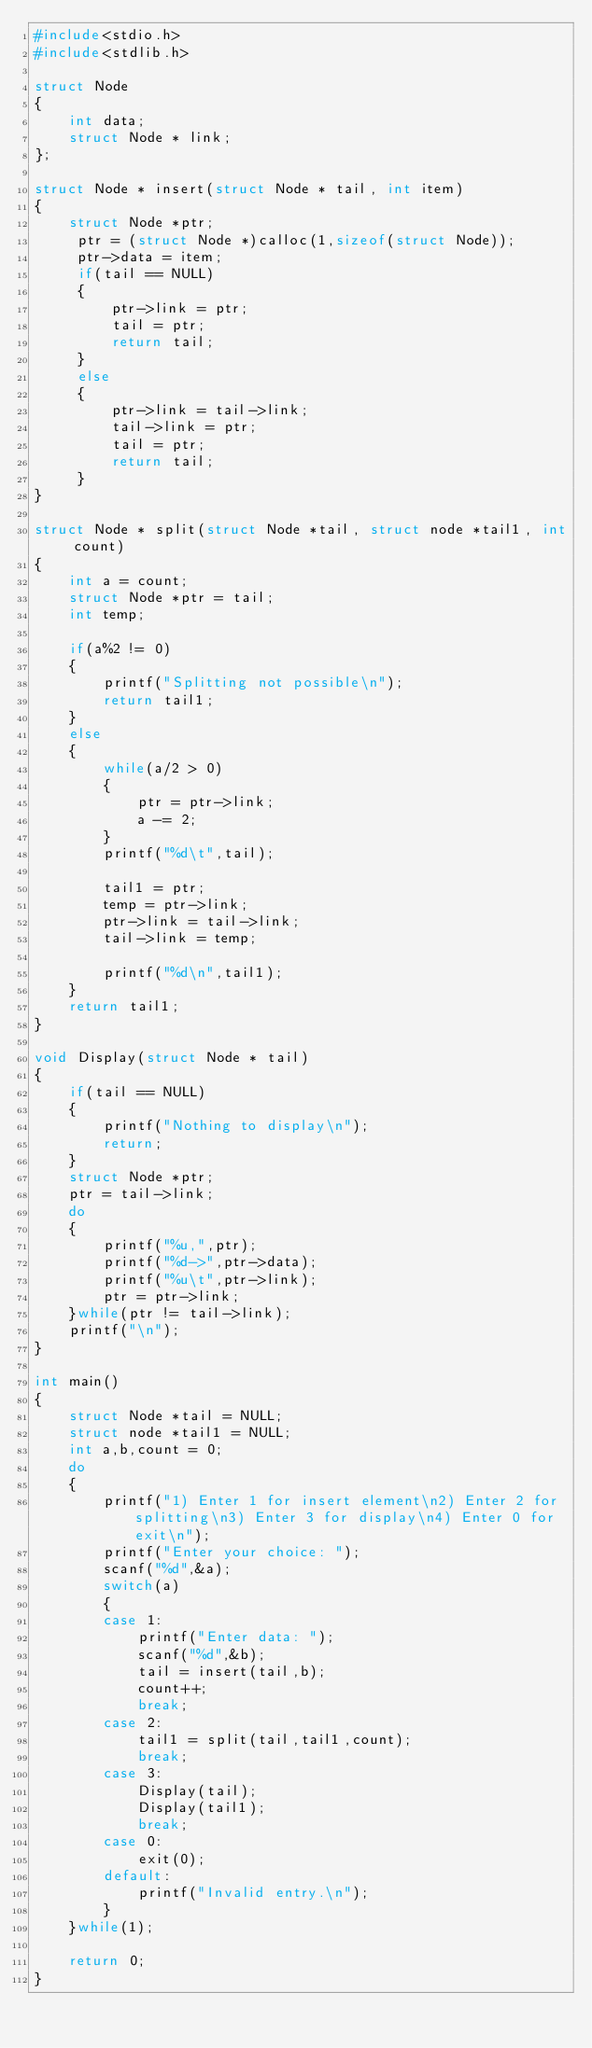Convert code to text. <code><loc_0><loc_0><loc_500><loc_500><_C_>#include<stdio.h>
#include<stdlib.h>

struct Node
{
    int data;
    struct Node * link;
};

struct Node * insert(struct Node * tail, int item)
{
    struct Node *ptr;
     ptr = (struct Node *)calloc(1,sizeof(struct Node));
     ptr->data = item;
     if(tail == NULL)
     {
         ptr->link = ptr;
         tail = ptr;
         return tail;
     }
     else
     {
         ptr->link = tail->link;
         tail->link = ptr;
         tail = ptr;
         return tail;
     }
}

struct Node * split(struct Node *tail, struct node *tail1, int count)
{
    int a = count;
    struct Node *ptr = tail;
    int temp;

    if(a%2 != 0)
    {
        printf("Splitting not possible\n");
        return tail1;
    }
    else
    {
        while(a/2 > 0)
        {
            ptr = ptr->link;
            a -= 2;
        }
        printf("%d\t",tail);

        tail1 = ptr;
        temp = ptr->link;
        ptr->link = tail->link;
        tail->link = temp;

        printf("%d\n",tail1);
    }
    return tail1;
}

void Display(struct Node * tail)
{
    if(tail == NULL)
    {
        printf("Nothing to display\n");
        return;
    }
    struct Node *ptr;
    ptr = tail->link;
    do
    {
        printf("%u,",ptr);
        printf("%d->",ptr->data);
        printf("%u\t",ptr->link);
        ptr = ptr->link;
    }while(ptr != tail->link);
    printf("\n");
}

int main()
{
    struct Node *tail = NULL;
    struct node *tail1 = NULL;
    int a,b,count = 0;
    do
    {
        printf("1) Enter 1 for insert element\n2) Enter 2 for splitting\n3) Enter 3 for display\n4) Enter 0 for exit\n");
        printf("Enter your choice: ");
        scanf("%d",&a);
        switch(a)
        {
        case 1:
            printf("Enter data: ");
            scanf("%d",&b);
            tail = insert(tail,b);
            count++;
            break;
        case 2:
            tail1 = split(tail,tail1,count);
            break;
        case 3:
            Display(tail);
            Display(tail1);
            break;
        case 0:
            exit(0);
        default:
            printf("Invalid entry.\n");
        }
    }while(1);

    return 0;
}
</code> 